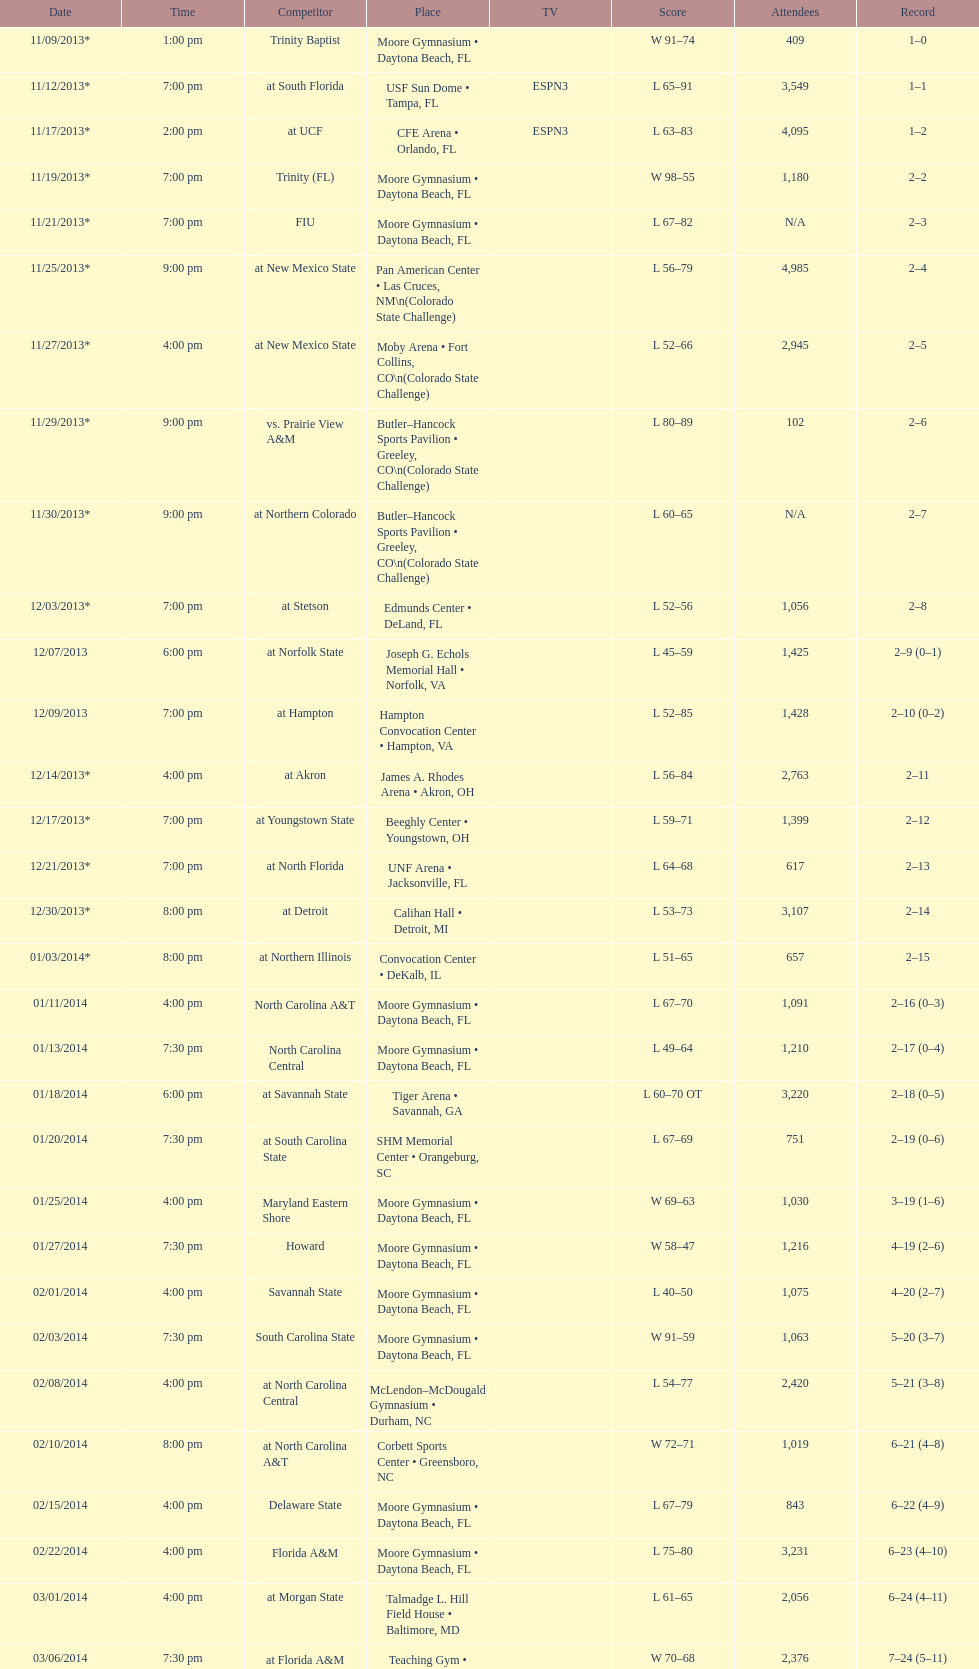How many teams had at most an attendance of 1,000? 6. 